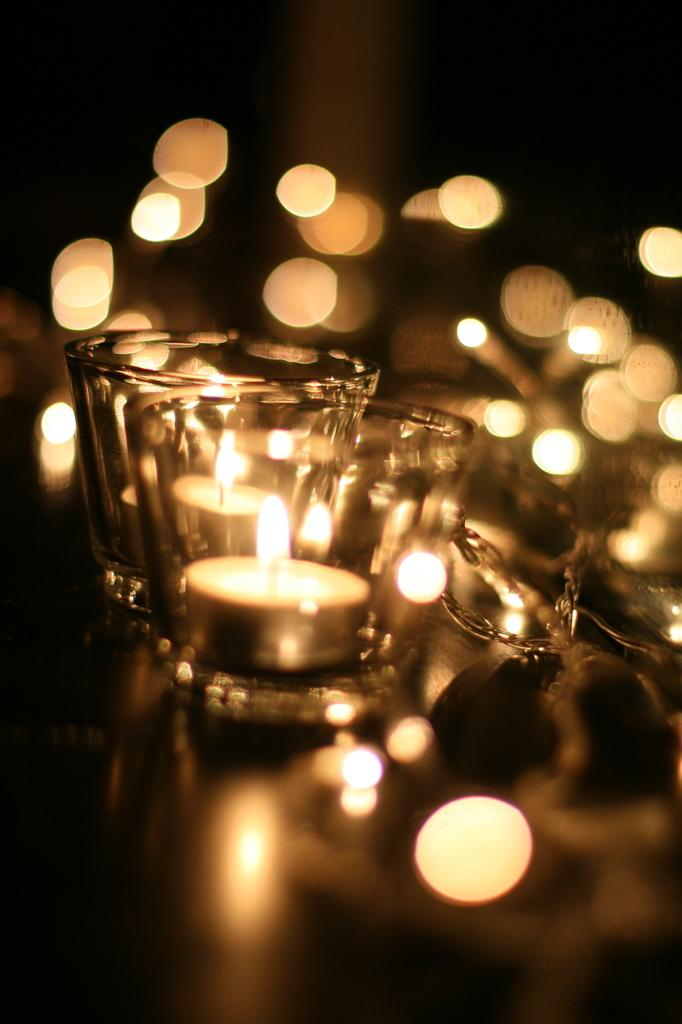How many glasses are present in the image? There are two glasses in the image. What is inside each glass? Each glass contains a candle. What is the state of the candles in the image? The candles have fire. How does the learning process take place in the image? There is no learning process depicted in the image; it features two glasses with candles that have fire. Can you describe the kick performed by the candles in the image? The candles in the image do not perform any kicks; they are stationary and have fire. 